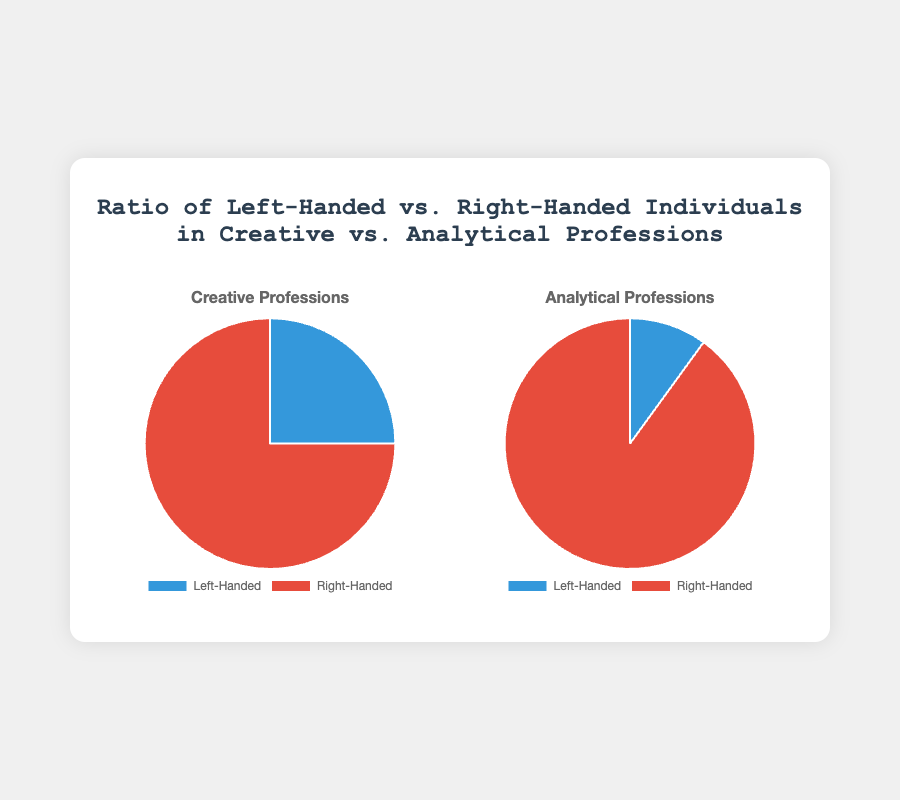What is the percentage of left-handed individuals in creative professions? The figure shows that the left-handed percentage for creative professions is 25%.
Answer: 25% What is the percentage of right-handed individuals in creative professions? The figure shows that the right-handed percentage for creative professions is 75%.
Answer: 75% What is the difference in the percentage of left-handed individuals between creative and analytical professions? The left-handed percentage for creative professions is 25%, while for analytical professions it is 10%. The difference is 25% - 10% = 15%.
Answer: 15% Which profession category has a higher percentage of right-handed individuals? The right-handed percentage in analytical professions is 90%, which is higher than the 75% in creative professions.
Answer: Analytical professions What is the ratio of left-handed to right-handed individuals in analytical professions? In analytical professions, the left-handed percentage is 10% and the right-handed percentage is 90%. The ratio is 10:90, which simplifies to 1:9.
Answer: 1:9 If 100 people are sampled from creative professions, how many of them are expected to be left-handed? The left-handed percentage in creative professions is 25%. Therefore, out of 100 people, 25% of 100 is 0.25 * 100 = 25 people.
Answer: 25 What is the total percentage distribution of left-handed and right-handed individuals across both profession categories combined? The figure doesn't provide combined data directly. However, for an accurate answer, you need detailed group sizes. Assuming equal numbers, it would be the mean: (25 + 10) / 2. For left-handed, it's (25 + 10) / 2 = 17.5%. For right-handed, it's (75 + 90) / 2 = 82.5%.
Answer: 17.5% left-handed, 82.5% right-handed Visualize the colors used for left-handed and right-handed groups in the pie charts. What are they? The pie charts use blue color for left-handed individuals and red color for right-handed individuals.
Answer: Blue, Red 